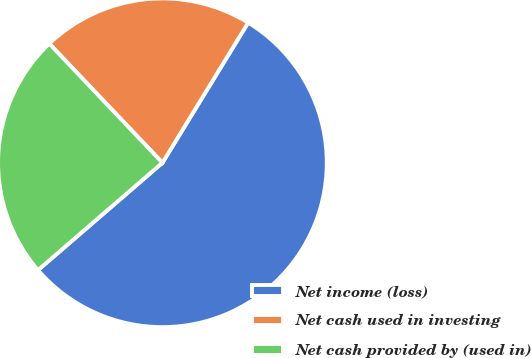Convert chart. <chart><loc_0><loc_0><loc_500><loc_500><pie_chart><fcel>Net income (loss)<fcel>Net cash used in investing<fcel>Net cash provided by (used in)<nl><fcel>54.94%<fcel>20.83%<fcel>24.24%<nl></chart> 